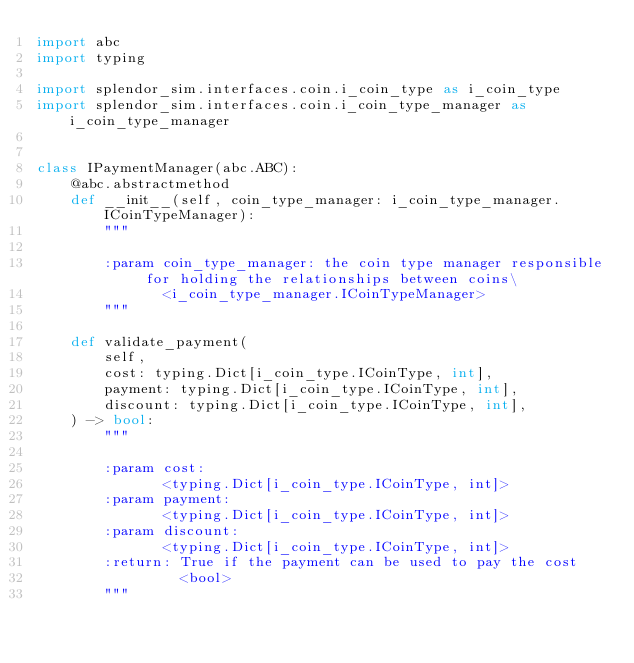<code> <loc_0><loc_0><loc_500><loc_500><_Python_>import abc
import typing

import splendor_sim.interfaces.coin.i_coin_type as i_coin_type
import splendor_sim.interfaces.coin.i_coin_type_manager as i_coin_type_manager


class IPaymentManager(abc.ABC):
    @abc.abstractmethod
    def __init__(self, coin_type_manager: i_coin_type_manager.ICoinTypeManager):
        """

        :param coin_type_manager: the coin type manager responsible for holding the relationships between coins\
               <i_coin_type_manager.ICoinTypeManager>
        """

    def validate_payment(
        self,
        cost: typing.Dict[i_coin_type.ICoinType, int],
        payment: typing.Dict[i_coin_type.ICoinType, int],
        discount: typing.Dict[i_coin_type.ICoinType, int],
    ) -> bool:
        """

        :param cost:
               <typing.Dict[i_coin_type.ICoinType, int]>
        :param payment:
               <typing.Dict[i_coin_type.ICoinType, int]>
        :param discount:
               <typing.Dict[i_coin_type.ICoinType, int]>
        :return: True if the payment can be used to pay the cost
                 <bool>
        """
</code> 